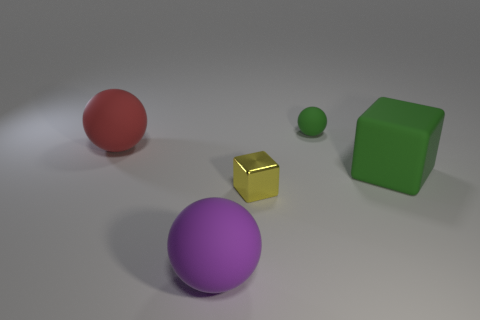Add 5 small green rubber spheres. How many objects exist? 10 Subtract all balls. How many objects are left? 2 Subtract all tiny green balls. Subtract all small yellow blocks. How many objects are left? 3 Add 5 rubber objects. How many rubber objects are left? 9 Add 5 large gray shiny objects. How many large gray shiny objects exist? 5 Subtract 0 cyan cylinders. How many objects are left? 5 